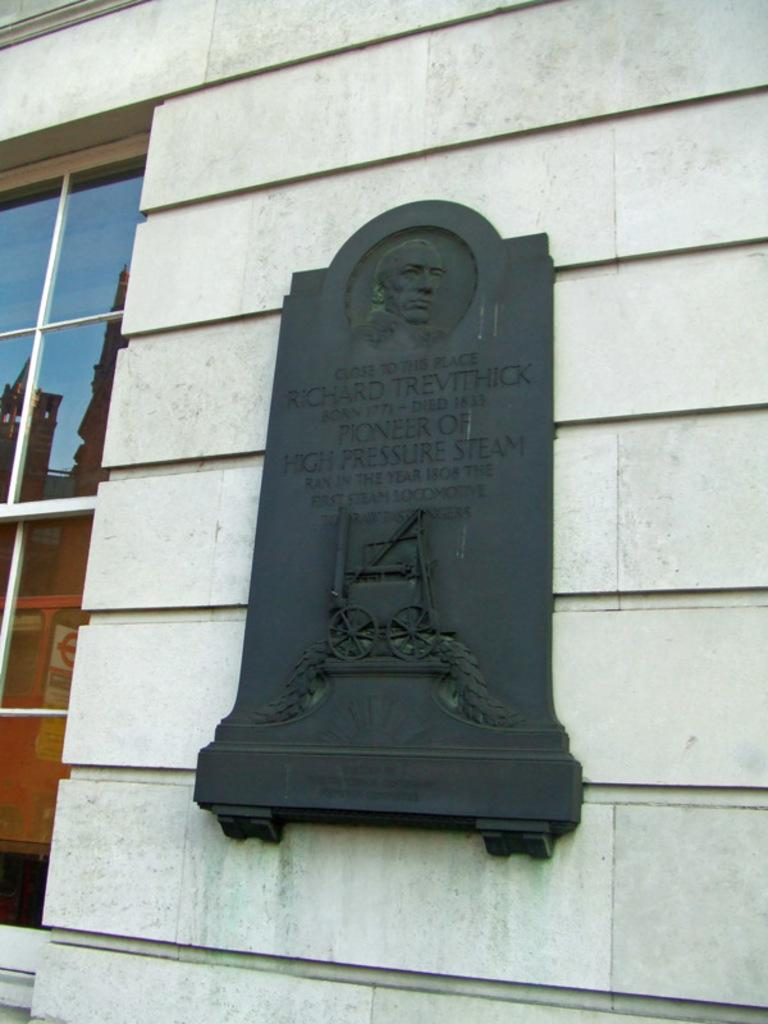What is the main subject of the image? There is a memorial in the image. How is the memorial positioned in the image? The memorial is attached to a wall. What can be seen on the left side of the image? There is a glass window on the left side of the image. How many bulbs are illuminating the memorial in the image? There is no mention of bulbs in the image, so it is impossible to determine how many are present or if they are illuminating the memorial. 